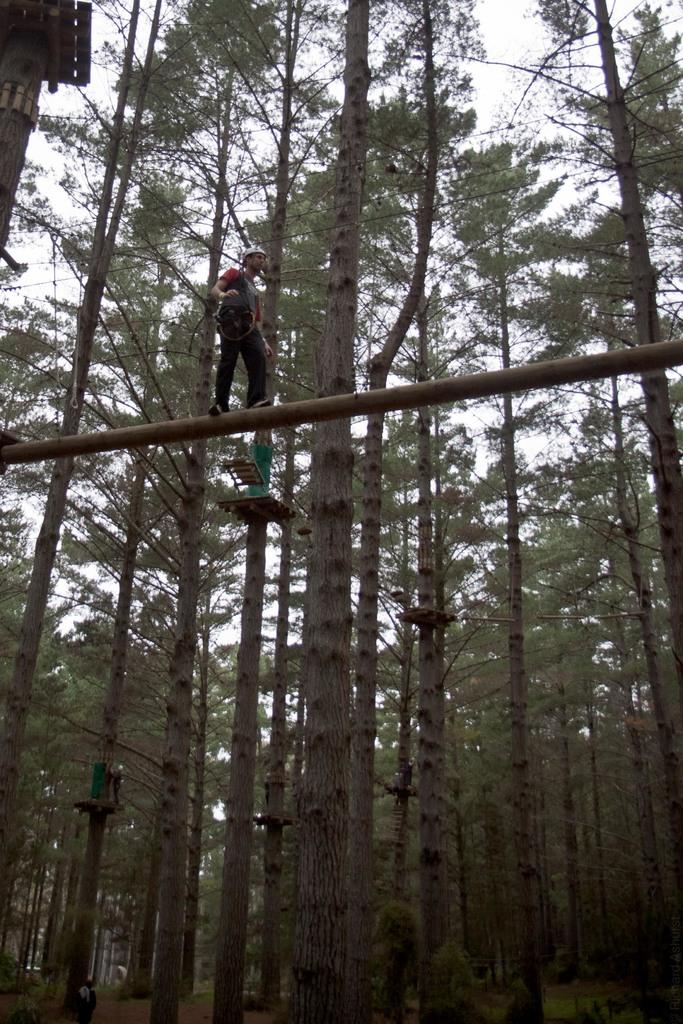What is the main subject of the image? There is a person walking in the image. What type of surface is the person walking on? The person is walking on wood. What type of vegetation can be seen in the image? There are green trees in the image. What is visible at the top of the image? The sky is visible at the top of the image. How many birds are flying over the seashore in the image? There is no seashore or birds present in the image; it features a person walking on wood with green trees in the background. 